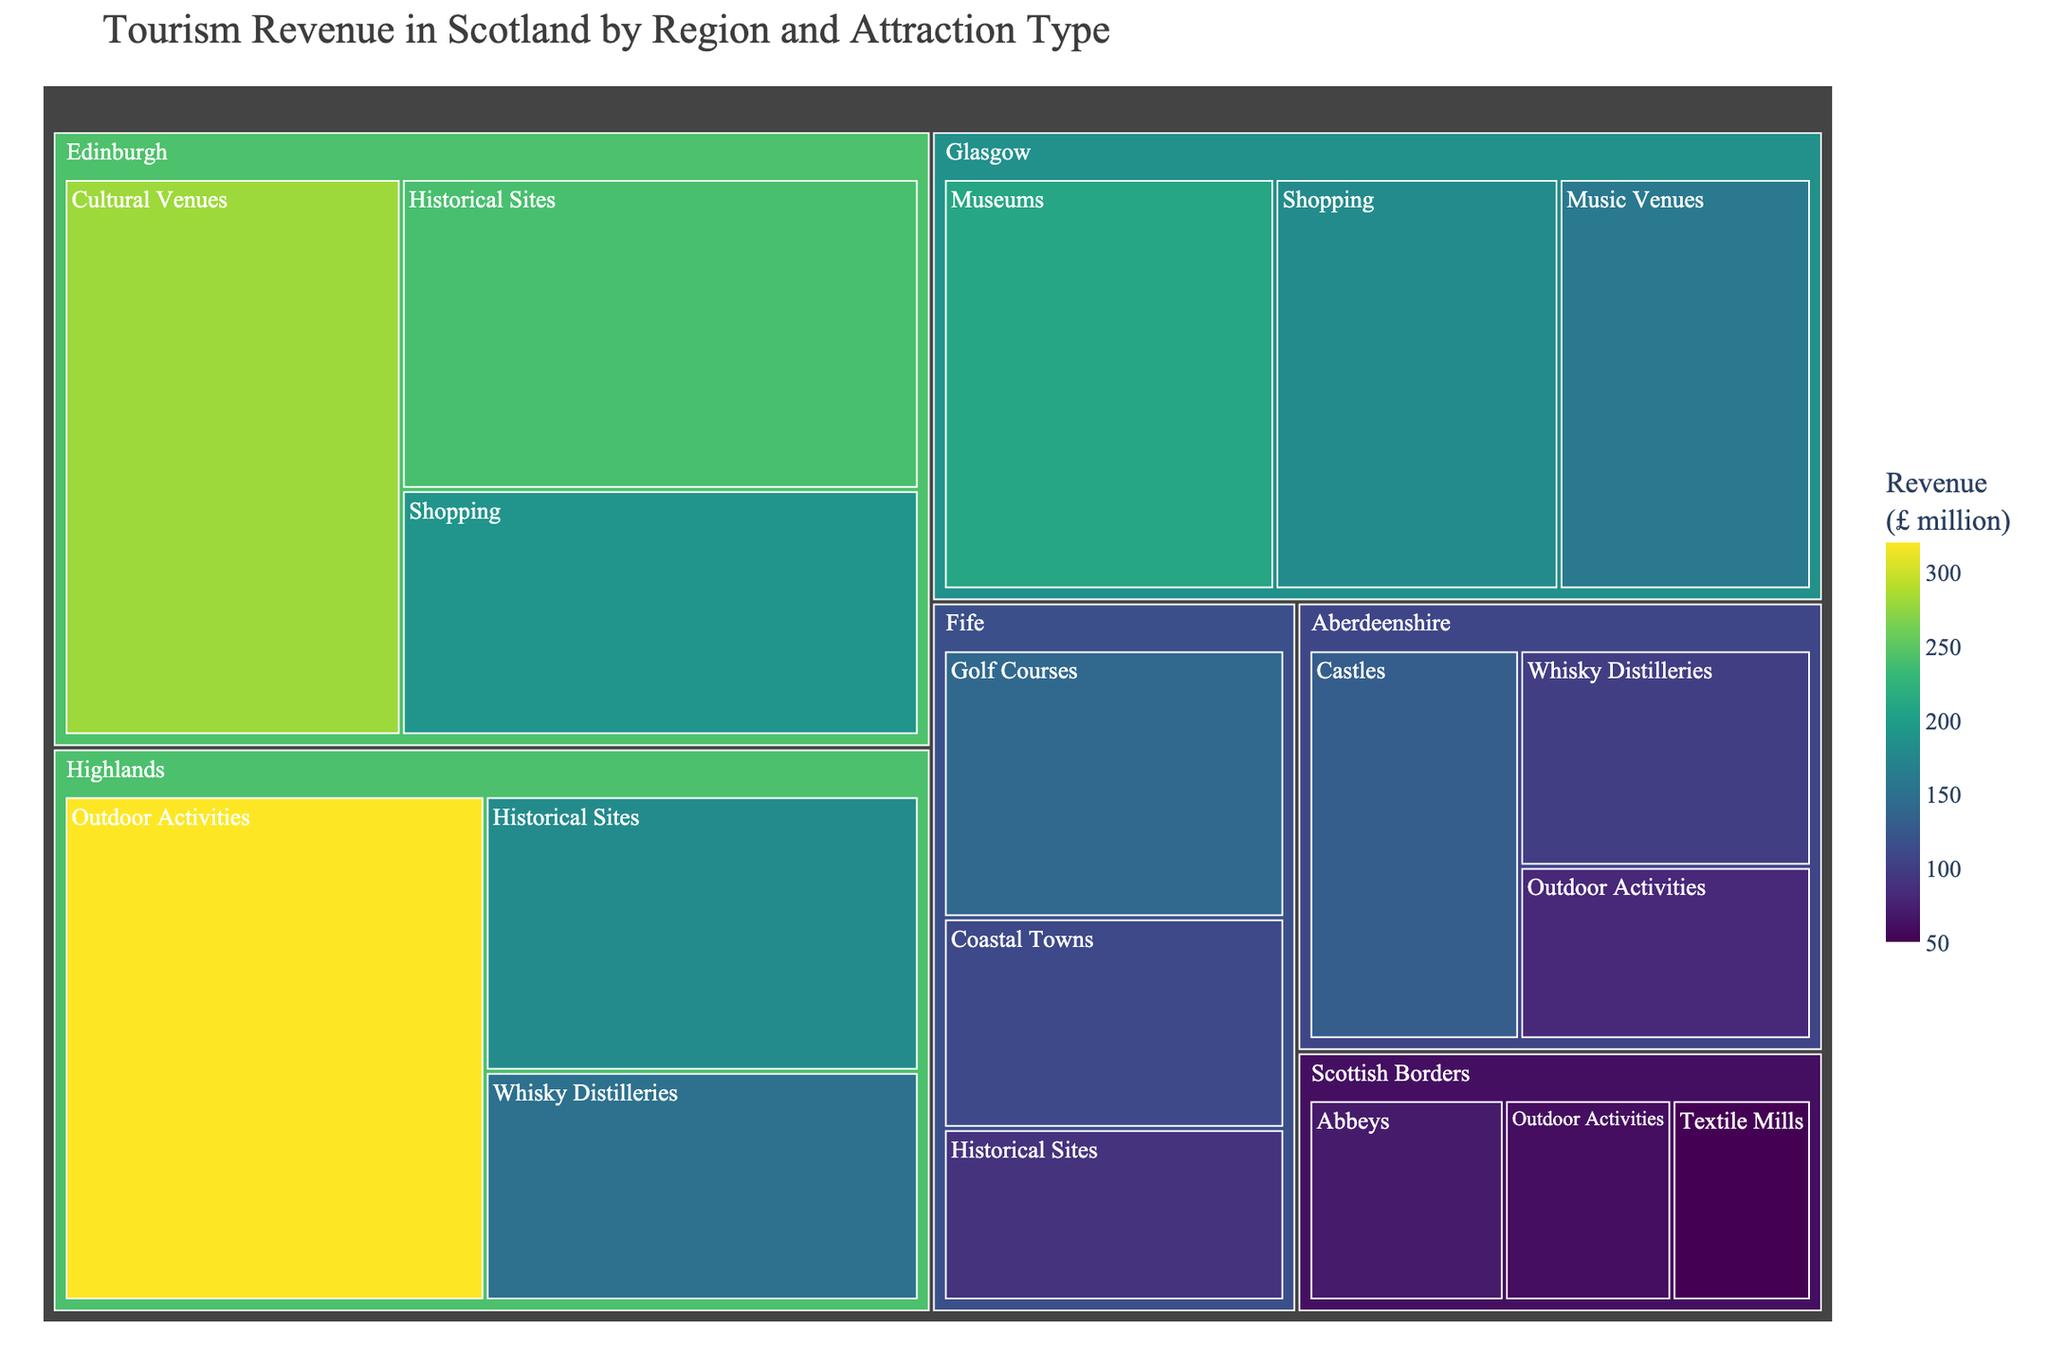What is the title of the figure? The title of the figure is written at the top of the chart.
Answer: Tourism Revenue in Scotland by Region and Attraction Type Which region generates the highest tourism revenue from 'Historical Sites'? Locate the regions with 'Historical Sites' in the treemap and compare their values. Edinburgh generates £240 million, Highlands £180 million, and Fife £90 million. Therefore, Edinburgh generates the highest revenue in this category.
Answer: Edinburgh How much revenue does 'Whisky Distilleries' bring in Aberdeenshire? Find 'Aberdeenshire' in the treemap, then locate the 'Whisky Distilleries' section within it. The revenue is listed, which is £100 million.
Answer: £100 million Comparing 'Shopping' revenues, which region earns more, Glasgow or Edinburgh? Identify and compare the 'Shopping' sections under Glasgow and Edinburgh. Glasgow earns £180 million, and Edinburgh earns £190 million. Hence, Edinburgh earns more.
Answer: Edinburgh What is the total revenue generated by the Highlands region? Sum all revenue values under the Highlands region: Outdoor Activities (£320 million) + Historical Sites (£180 million) + Whisky Distilleries (£150 million). The total is £320 + £180 + £150 = £650 million.
Answer: £650 million Which region generates more revenue from 'Outdoor Activities', Highlands or Aberdeenshire? Look at the 'Outdoor Activities' revenue for both regions. Highlands earns £320 million, and Aberdeenshire earns £80 million from this activity. Highlands generates more revenue.
Answer: Highlands What is the combined revenue from 'Cultural Venues' and 'Music Venues' in Edinburgh and Glasgow, respectively? Add the revenue from 'Cultural Venues' in Edinburgh (£280 million) and 'Music Venues' in Glasgow (£160 million). The total is £280 + £160 = £440 million.
Answer: £440 million How does revenue from 'Museums' in Glasgow compare to 'Historical Sites' in Edinburgh? Compare the values for 'Museums' in Glasgow (£210 million) and 'Historical Sites' in Edinburgh (£240 million). 'Historical Sites' in Edinburgh generates more revenue.
Answer: Historical Sites in Edinburgh Given the entire data, what is the lowest revenue-generating attraction type and its value? Identify the least revenue-generating section in the treemap. 'Textile Mills' in Scottish Borders generates the lowest revenue at £50 million.
Answer: Textile Mills, £50 million 